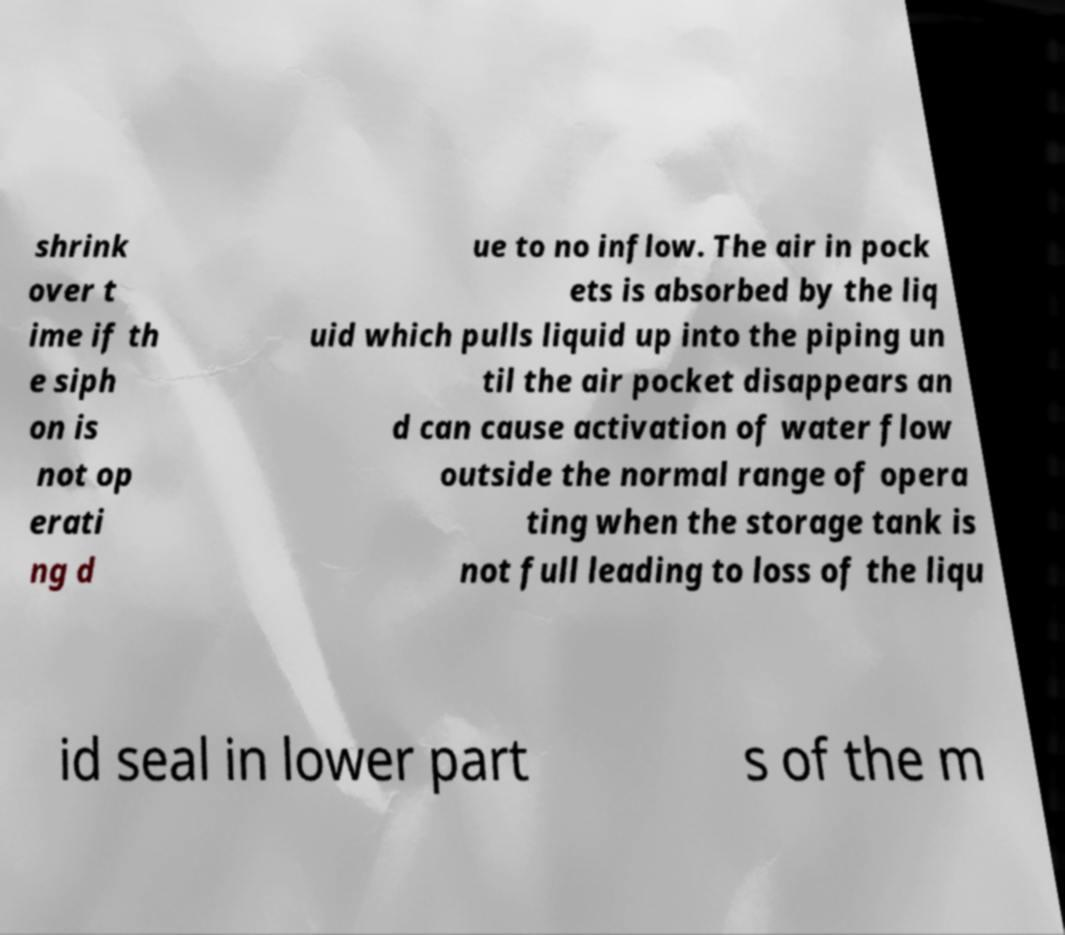For documentation purposes, I need the text within this image transcribed. Could you provide that? shrink over t ime if th e siph on is not op erati ng d ue to no inflow. The air in pock ets is absorbed by the liq uid which pulls liquid up into the piping un til the air pocket disappears an d can cause activation of water flow outside the normal range of opera ting when the storage tank is not full leading to loss of the liqu id seal in lower part s of the m 